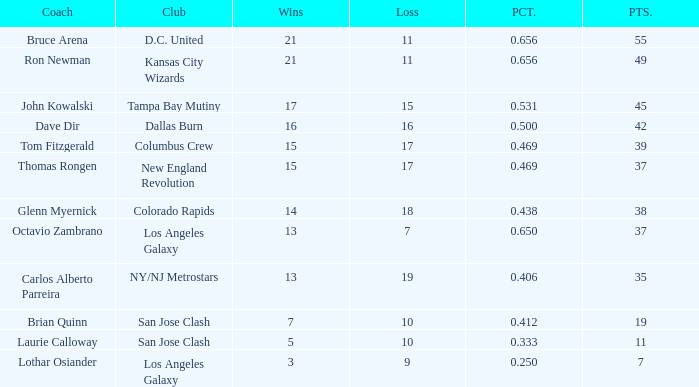What is the highest percent of Bruce Arena when he loses more than 11 games? None. 